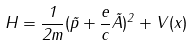<formula> <loc_0><loc_0><loc_500><loc_500>H = \frac { 1 } { 2 m } ( \vec { p } + \frac { e } { c } \vec { A } ) ^ { 2 } + V ( x )</formula> 